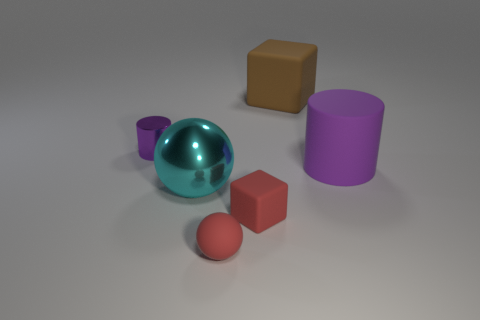Could you tell me what the shiny object is, and why it looks different from the others? The shiny object is a teal sphere with a reflective surface that distinguishes it from the other matte objects in the image. Its reflective quality creates a mirrored effect, allowing it to catch and cast back the light and colors from its surroundings, adding to its visual appeal. 